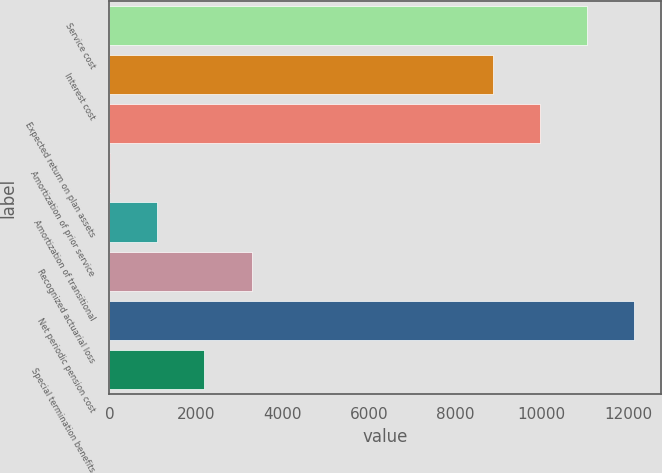<chart> <loc_0><loc_0><loc_500><loc_500><bar_chart><fcel>Service cost<fcel>Interest cost<fcel>Expected return on plan assets<fcel>Amortization of prior service<fcel>Amortization of transitional<fcel>Recognized actuarial loss<fcel>Net periodic pension cost<fcel>Special termination benefits<nl><fcel>11048.6<fcel>8862<fcel>9955.3<fcel>8<fcel>1101.3<fcel>3287.9<fcel>12141.9<fcel>2194.6<nl></chart> 